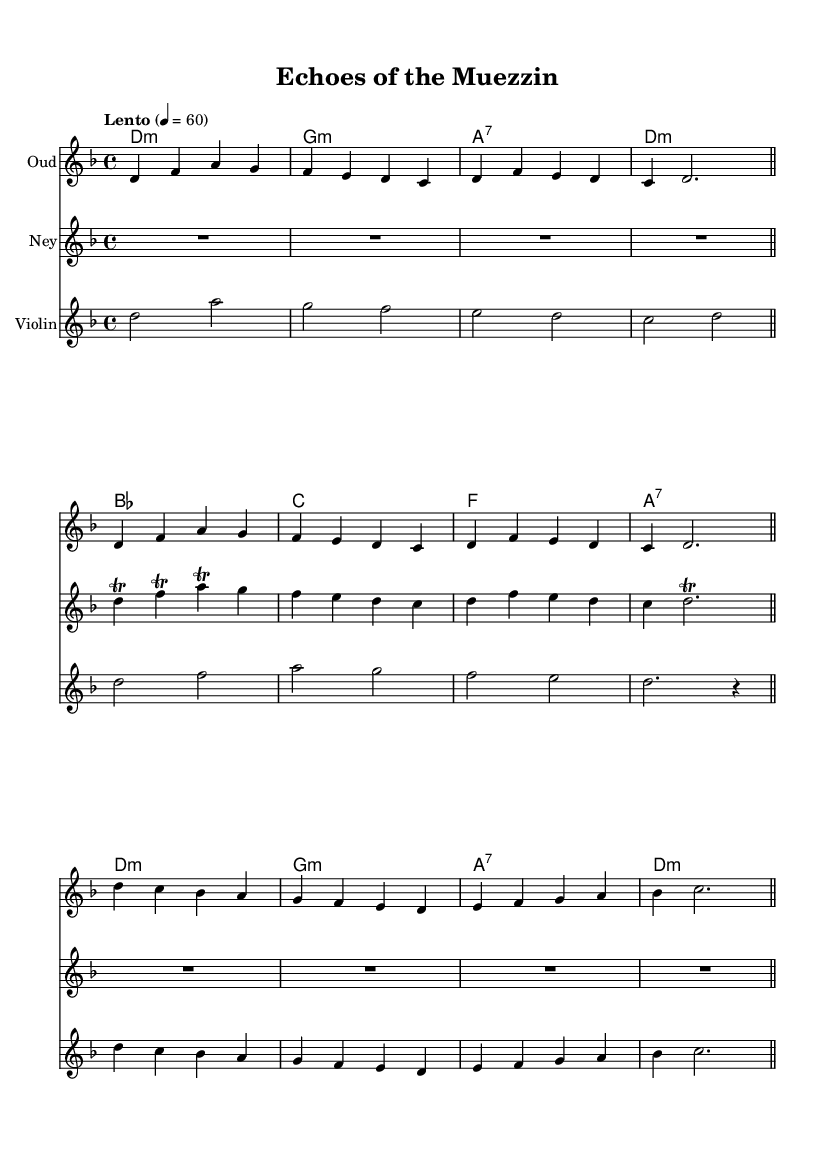What is the key signature of this music? The key signature is indicated right after the clef and shows two flats (B♭ and E♭), indicating D minor.
Answer: D minor What is the time signature of this composition? The time signature appears at the beginning and shows 4/4, indicating there are four beats in each measure.
Answer: 4/4 What is the tempo marking of this piece? The tempo marking is written in Italian and indicates a slow speed of 60 beats per minute.
Answer: Lento How many bars are there in the oud part? By visually counting the measures in the oud staff, you can see there are 8 measures total.
Answer: 8 Which instruments are used in this composition? The sheet clearly shows three different staves labeled "Oud," "Ney," and "Violin," indicating these instruments are used.
Answer: Oud, Ney, Violin What is the first note of the Ney part? The Ney part begins with a rest indicated by "R1", showing a pause before the music starts.
Answer: Rest What type of harmony is present in this composition? The harmony section shows a mix of minor and seventh chords, typical in pieces inspired by Islamic melodies.
Answer: Minor and seventh chords 